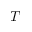Convert formula to latex. <formula><loc_0><loc_0><loc_500><loc_500>T</formula> 